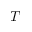Convert formula to latex. <formula><loc_0><loc_0><loc_500><loc_500>T</formula> 